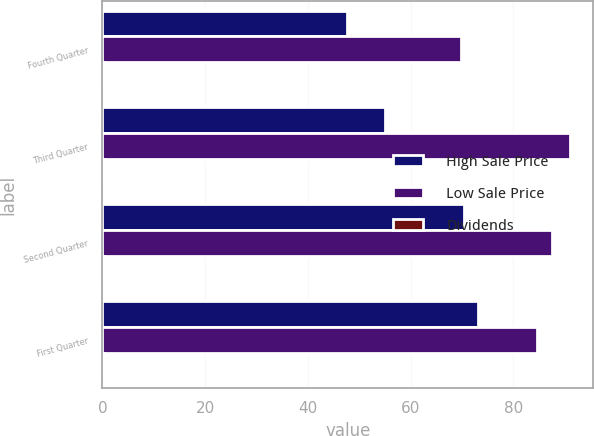Convert chart. <chart><loc_0><loc_0><loc_500><loc_500><stacked_bar_chart><ecel><fcel>Fourth Quarter<fcel>Third Quarter<fcel>Second Quarter<fcel>First Quarter<nl><fcel>High Sale Price<fcel>47.56<fcel>54.9<fcel>70.3<fcel>73.04<nl><fcel>Low Sale Price<fcel>69.87<fcel>90.95<fcel>87.44<fcel>84.66<nl><fcel>Dividends<fcel>0.27<fcel>0.27<fcel>0.27<fcel>0.27<nl></chart> 